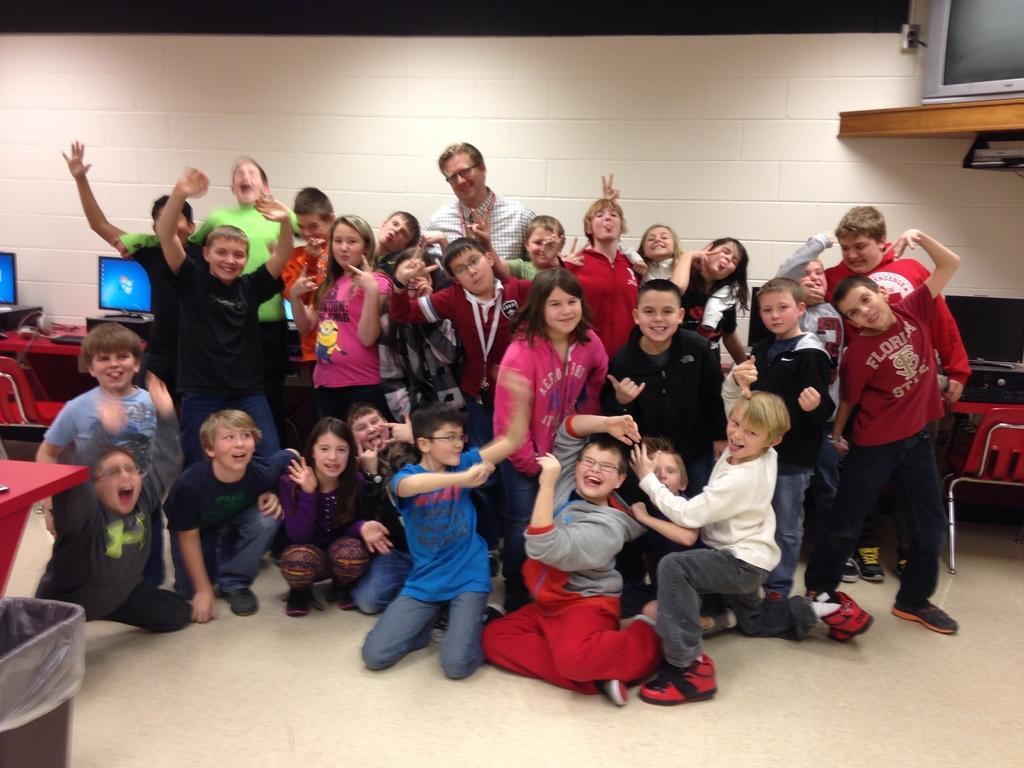Please provide a concise description of this image. In this image, there are a few people. We can see the ground and a table with some screens and objects. We can see some chairs. We can also see some objects on the bottom left. We can also see a wooden object with one of the screens on the top right corner. We can see the wall. 